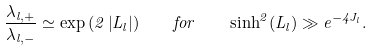<formula> <loc_0><loc_0><loc_500><loc_500>\frac { { \lambda _ { l , + } } } { { \lambda _ { l , - } } } \simeq \exp \left ( { 2 \left | { L _ { l } } \right | } \right ) \quad f o r \quad \sinh ^ { 2 } ( L _ { l } ) \gg e ^ { - 4 J _ { l } } .</formula> 